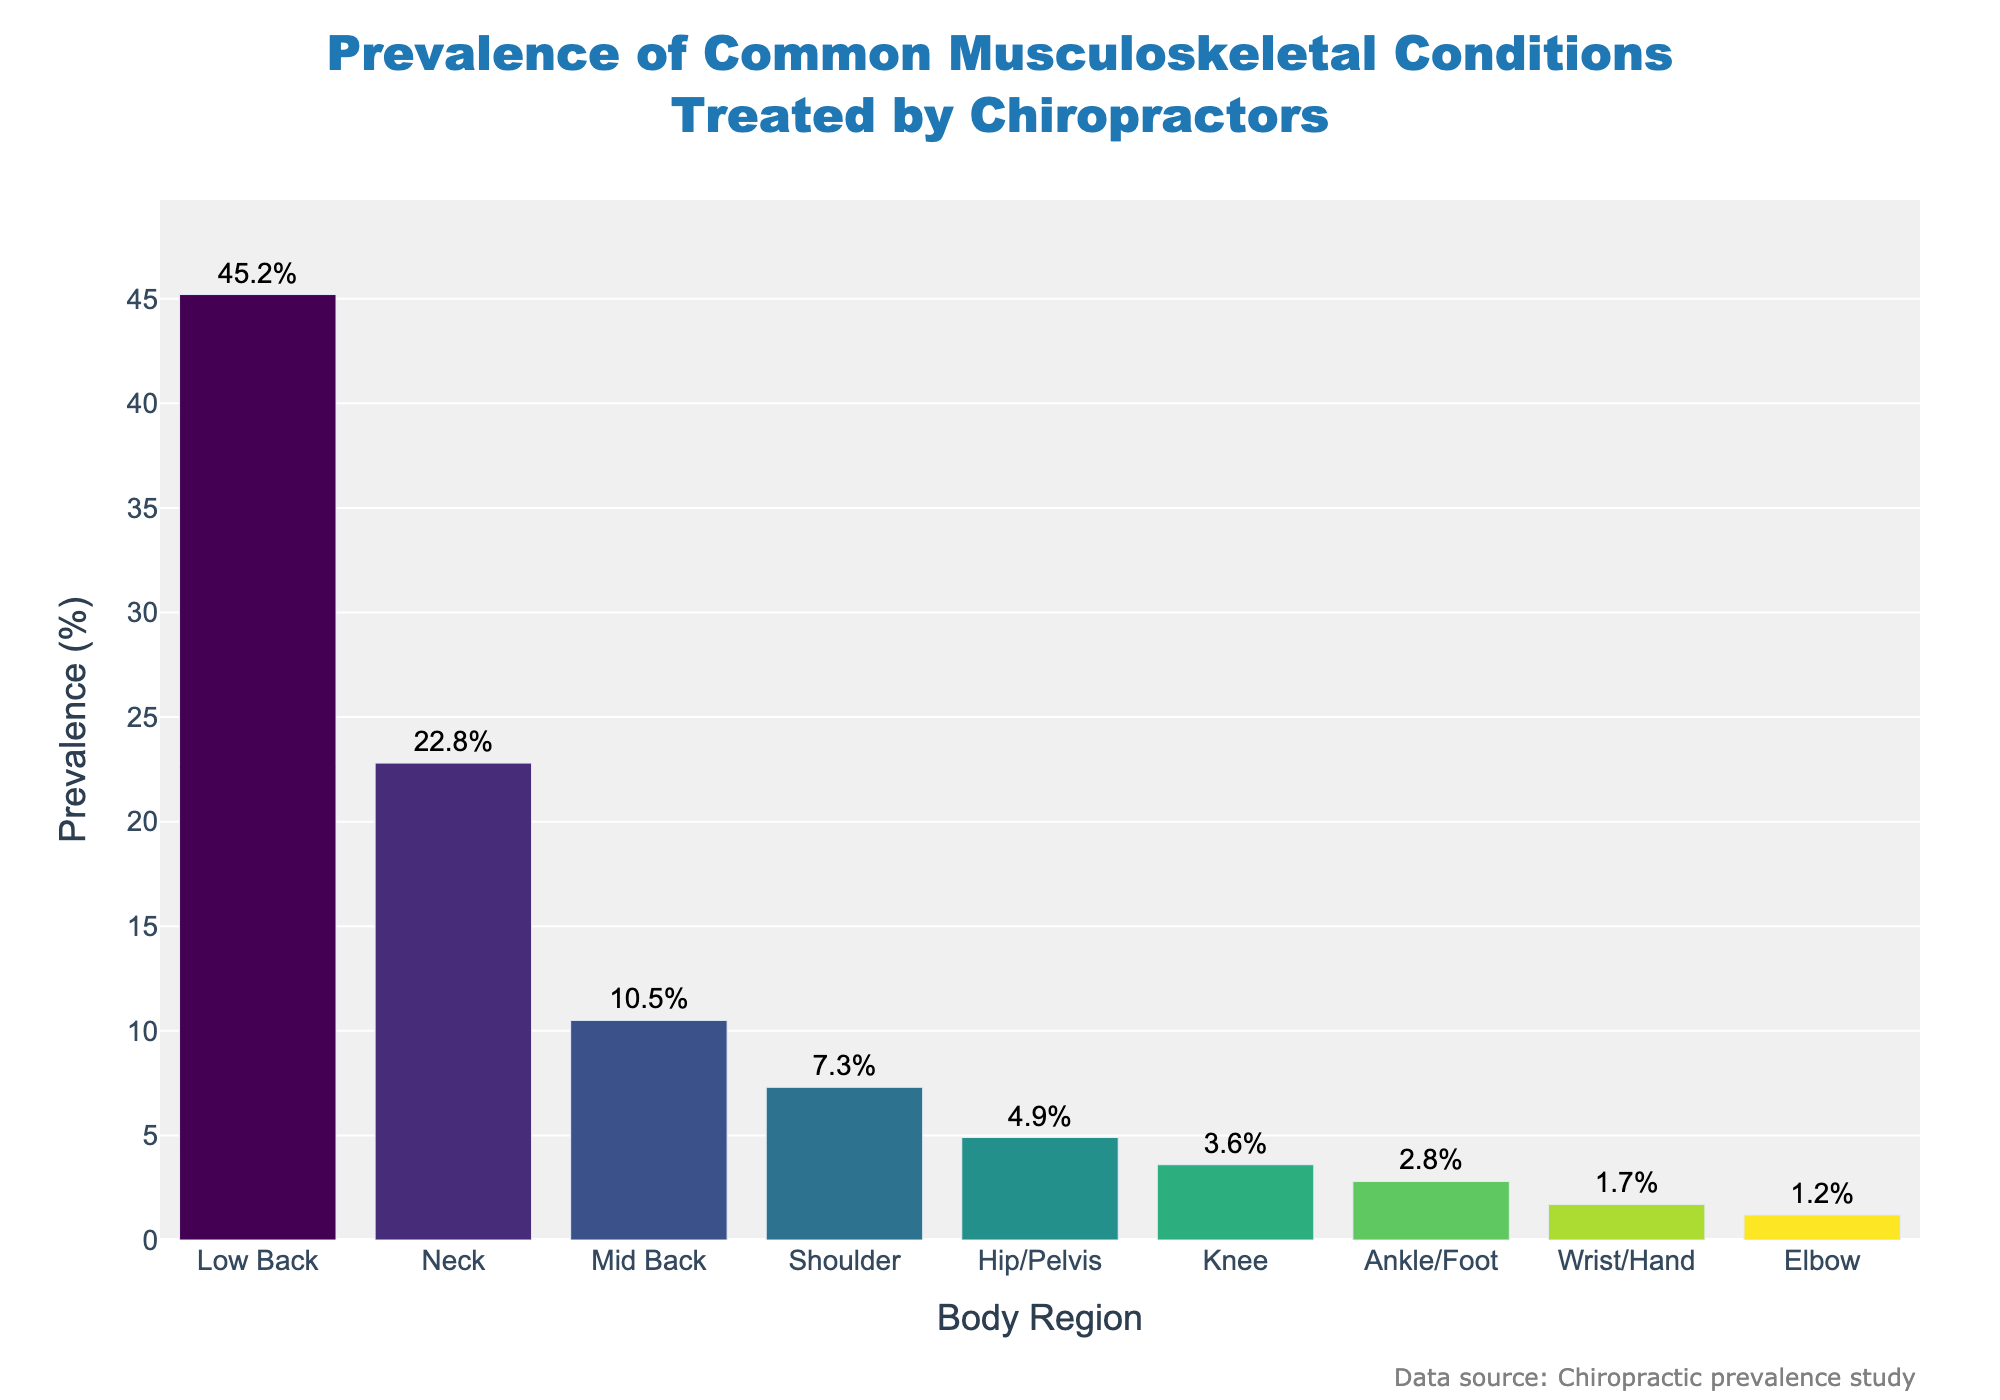what's the prevalence of low back conditions? The bar chart shows the prevalence of musculoskeletal conditions treated by chiropractors, with "Low Back" having the highest prevalence at 45.2%.
Answer: 45.2% What is the combined prevalence of shoulder, hip/pelvis, and knee conditions? From the bars, shoulder has a prevalence of 7.3%, hip/pelvis is 4.9%, and knee is 3.6%. Adding them together: 7.3% + 4.9% + 3.6% = 15.8%.
Answer: 15.8% Which body region has the lowest prevalence? The bar representing the "Elbow" has the shortest height, indicating it has the lowest prevalence at 1.2%.
Answer: Elbow How much higher is the prevalence of neck conditions compared to mid back conditions? Neck condition prevalence is 22.8% and mid back is 10.5%. The difference is 22.8% - 10.5% = 12.3%.
Answer: 12.3% Are wrist/hand conditions more prevalent than elbow conditions? The bar for wrist/hand is taller than the bar for elbow. Wrist/hand has a prevalence of 1.7%, while elbow has 1.2%.
Answer: Yes What's the average prevalence of all the conditions shown? To find the average, sum all the prevalences and divide by the number of body regions: (45.2 + 22.8 + 10.5 + 7.3 + 4.9 + 3.6 + 2.8 + 1.7 + 1.2) / 9 = 11.1%.
Answer: 11.1% Which body region has a prevalence closest to 5%? The "Hip/Pelvis" bar has a prevalence of 4.9%, which is closest to 5%.
Answer: Hip/Pelvis Is the combined prevalence of neck and mid back conditions higher than that of low back conditions? Neck prevalence is 22.8% and mid back is 10.5%. Combined, this is 22.8% + 10.5% = 33.3%. Comparing with low back which is 45.2%, 33.3% is less than 45.2%.
Answer: No By how much does the prevalence of knee conditions exceed that of ankle/foot conditions? Knee condition prevalence is 3.6%, and ankle/foot is 2.8%. The difference is 3.6% - 2.8% = 0.8%.
Answer: 0.8% 